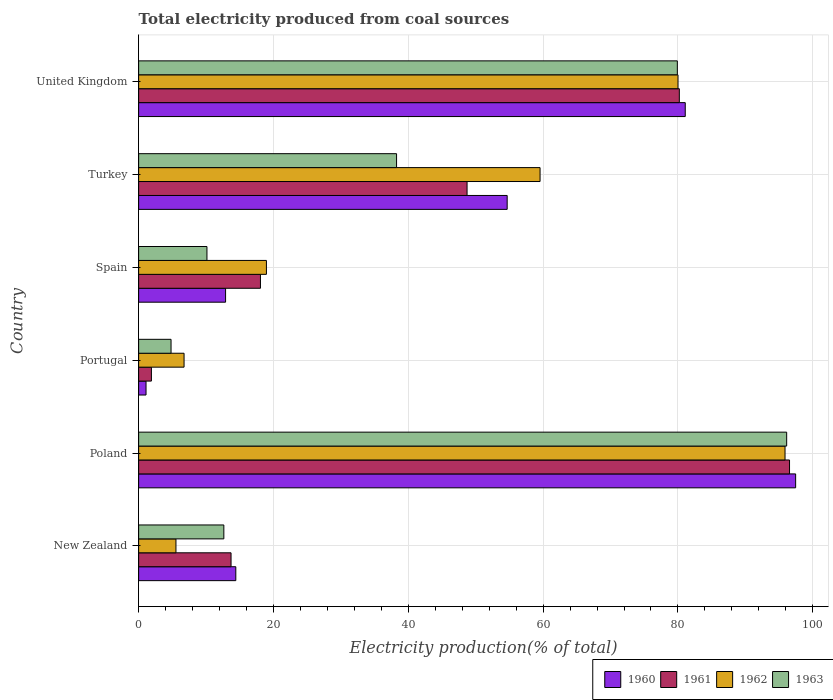How many different coloured bars are there?
Provide a short and direct response. 4. How many groups of bars are there?
Your response must be concise. 6. Are the number of bars on each tick of the Y-axis equal?
Provide a succinct answer. Yes. How many bars are there on the 6th tick from the top?
Ensure brevity in your answer.  4. How many bars are there on the 4th tick from the bottom?
Keep it short and to the point. 4. What is the label of the 6th group of bars from the top?
Provide a succinct answer. New Zealand. What is the total electricity produced in 1961 in Portugal?
Your answer should be compact. 1.89. Across all countries, what is the maximum total electricity produced in 1961?
Provide a short and direct response. 96.56. Across all countries, what is the minimum total electricity produced in 1962?
Provide a short and direct response. 5.54. In which country was the total electricity produced in 1963 maximum?
Keep it short and to the point. Poland. In which country was the total electricity produced in 1962 minimum?
Your answer should be very brief. New Zealand. What is the total total electricity produced in 1960 in the graph?
Your answer should be compact. 261.63. What is the difference between the total electricity produced in 1960 in Portugal and that in Spain?
Ensure brevity in your answer.  -11.8. What is the difference between the total electricity produced in 1963 in Poland and the total electricity produced in 1961 in Spain?
Offer a very short reply. 78.06. What is the average total electricity produced in 1960 per country?
Your answer should be compact. 43.61. What is the difference between the total electricity produced in 1962 and total electricity produced in 1960 in New Zealand?
Your answer should be compact. -8.88. What is the ratio of the total electricity produced in 1960 in Poland to that in United Kingdom?
Provide a succinct answer. 1.2. Is the difference between the total electricity produced in 1962 in Portugal and Turkey greater than the difference between the total electricity produced in 1960 in Portugal and Turkey?
Your answer should be very brief. Yes. What is the difference between the highest and the second highest total electricity produced in 1961?
Make the answer very short. 16.35. What is the difference between the highest and the lowest total electricity produced in 1960?
Your answer should be very brief. 96.36. In how many countries, is the total electricity produced in 1960 greater than the average total electricity produced in 1960 taken over all countries?
Provide a succinct answer. 3. What does the 4th bar from the top in Poland represents?
Offer a very short reply. 1960. What is the difference between two consecutive major ticks on the X-axis?
Offer a very short reply. 20. Are the values on the major ticks of X-axis written in scientific E-notation?
Provide a short and direct response. No. Does the graph contain grids?
Offer a terse response. Yes. Where does the legend appear in the graph?
Offer a terse response. Bottom right. How are the legend labels stacked?
Provide a succinct answer. Horizontal. What is the title of the graph?
Your answer should be compact. Total electricity produced from coal sources. Does "2012" appear as one of the legend labels in the graph?
Your response must be concise. No. What is the label or title of the Y-axis?
Make the answer very short. Country. What is the Electricity production(% of total) in 1960 in New Zealand?
Your answer should be very brief. 14.42. What is the Electricity production(% of total) of 1961 in New Zealand?
Offer a very short reply. 13.71. What is the Electricity production(% of total) of 1962 in New Zealand?
Offer a very short reply. 5.54. What is the Electricity production(% of total) in 1963 in New Zealand?
Make the answer very short. 12.64. What is the Electricity production(% of total) in 1960 in Poland?
Your response must be concise. 97.46. What is the Electricity production(% of total) of 1961 in Poland?
Your response must be concise. 96.56. What is the Electricity production(% of total) of 1962 in Poland?
Ensure brevity in your answer.  95.89. What is the Electricity production(% of total) of 1963 in Poland?
Make the answer very short. 96.13. What is the Electricity production(% of total) of 1960 in Portugal?
Ensure brevity in your answer.  1.1. What is the Electricity production(% of total) of 1961 in Portugal?
Provide a short and direct response. 1.89. What is the Electricity production(% of total) of 1962 in Portugal?
Keep it short and to the point. 6.74. What is the Electricity production(% of total) of 1963 in Portugal?
Your response must be concise. 4.81. What is the Electricity production(% of total) in 1960 in Spain?
Keep it short and to the point. 12.9. What is the Electricity production(% of total) of 1961 in Spain?
Your answer should be very brief. 18.07. What is the Electricity production(% of total) in 1962 in Spain?
Make the answer very short. 18.96. What is the Electricity production(% of total) in 1963 in Spain?
Your response must be concise. 10.14. What is the Electricity production(% of total) of 1960 in Turkey?
Your response must be concise. 54.67. What is the Electricity production(% of total) of 1961 in Turkey?
Provide a short and direct response. 48.72. What is the Electricity production(% of total) in 1962 in Turkey?
Ensure brevity in your answer.  59.55. What is the Electricity production(% of total) of 1963 in Turkey?
Offer a terse response. 38.26. What is the Electricity production(% of total) in 1960 in United Kingdom?
Give a very brief answer. 81.09. What is the Electricity production(% of total) in 1961 in United Kingdom?
Make the answer very short. 80.21. What is the Electricity production(% of total) of 1962 in United Kingdom?
Provide a short and direct response. 80.01. What is the Electricity production(% of total) in 1963 in United Kingdom?
Your response must be concise. 79.91. Across all countries, what is the maximum Electricity production(% of total) of 1960?
Offer a very short reply. 97.46. Across all countries, what is the maximum Electricity production(% of total) in 1961?
Your response must be concise. 96.56. Across all countries, what is the maximum Electricity production(% of total) in 1962?
Give a very brief answer. 95.89. Across all countries, what is the maximum Electricity production(% of total) in 1963?
Your answer should be very brief. 96.13. Across all countries, what is the minimum Electricity production(% of total) in 1960?
Your answer should be compact. 1.1. Across all countries, what is the minimum Electricity production(% of total) of 1961?
Make the answer very short. 1.89. Across all countries, what is the minimum Electricity production(% of total) of 1962?
Ensure brevity in your answer.  5.54. Across all countries, what is the minimum Electricity production(% of total) in 1963?
Your answer should be very brief. 4.81. What is the total Electricity production(% of total) of 1960 in the graph?
Your answer should be compact. 261.63. What is the total Electricity production(% of total) in 1961 in the graph?
Ensure brevity in your answer.  259.16. What is the total Electricity production(% of total) of 1962 in the graph?
Your answer should be compact. 266.69. What is the total Electricity production(% of total) of 1963 in the graph?
Your answer should be compact. 241.89. What is the difference between the Electricity production(% of total) of 1960 in New Zealand and that in Poland?
Make the answer very short. -83.05. What is the difference between the Electricity production(% of total) of 1961 in New Zealand and that in Poland?
Offer a very short reply. -82.85. What is the difference between the Electricity production(% of total) in 1962 in New Zealand and that in Poland?
Keep it short and to the point. -90.35. What is the difference between the Electricity production(% of total) in 1963 in New Zealand and that in Poland?
Provide a short and direct response. -83.49. What is the difference between the Electricity production(% of total) in 1960 in New Zealand and that in Portugal?
Ensure brevity in your answer.  13.32. What is the difference between the Electricity production(% of total) in 1961 in New Zealand and that in Portugal?
Provide a succinct answer. 11.81. What is the difference between the Electricity production(% of total) in 1962 in New Zealand and that in Portugal?
Provide a succinct answer. -1.2. What is the difference between the Electricity production(% of total) in 1963 in New Zealand and that in Portugal?
Offer a terse response. 7.83. What is the difference between the Electricity production(% of total) in 1960 in New Zealand and that in Spain?
Ensure brevity in your answer.  1.52. What is the difference between the Electricity production(% of total) of 1961 in New Zealand and that in Spain?
Your answer should be compact. -4.36. What is the difference between the Electricity production(% of total) in 1962 in New Zealand and that in Spain?
Give a very brief answer. -13.42. What is the difference between the Electricity production(% of total) in 1963 in New Zealand and that in Spain?
Give a very brief answer. 2.5. What is the difference between the Electricity production(% of total) of 1960 in New Zealand and that in Turkey?
Offer a very short reply. -40.25. What is the difference between the Electricity production(% of total) of 1961 in New Zealand and that in Turkey?
Ensure brevity in your answer.  -35.01. What is the difference between the Electricity production(% of total) in 1962 in New Zealand and that in Turkey?
Provide a succinct answer. -54.01. What is the difference between the Electricity production(% of total) of 1963 in New Zealand and that in Turkey?
Make the answer very short. -25.62. What is the difference between the Electricity production(% of total) of 1960 in New Zealand and that in United Kingdom?
Keep it short and to the point. -66.67. What is the difference between the Electricity production(% of total) in 1961 in New Zealand and that in United Kingdom?
Keep it short and to the point. -66.5. What is the difference between the Electricity production(% of total) in 1962 in New Zealand and that in United Kingdom?
Your answer should be compact. -74.48. What is the difference between the Electricity production(% of total) in 1963 in New Zealand and that in United Kingdom?
Ensure brevity in your answer.  -67.27. What is the difference between the Electricity production(% of total) of 1960 in Poland and that in Portugal?
Provide a succinct answer. 96.36. What is the difference between the Electricity production(% of total) in 1961 in Poland and that in Portugal?
Give a very brief answer. 94.66. What is the difference between the Electricity production(% of total) in 1962 in Poland and that in Portugal?
Offer a terse response. 89.15. What is the difference between the Electricity production(% of total) of 1963 in Poland and that in Portugal?
Your answer should be very brief. 91.32. What is the difference between the Electricity production(% of total) in 1960 in Poland and that in Spain?
Make the answer very short. 84.56. What is the difference between the Electricity production(% of total) in 1961 in Poland and that in Spain?
Give a very brief answer. 78.49. What is the difference between the Electricity production(% of total) in 1962 in Poland and that in Spain?
Your answer should be compact. 76.93. What is the difference between the Electricity production(% of total) in 1963 in Poland and that in Spain?
Your answer should be very brief. 86. What is the difference between the Electricity production(% of total) of 1960 in Poland and that in Turkey?
Your answer should be compact. 42.79. What is the difference between the Electricity production(% of total) in 1961 in Poland and that in Turkey?
Make the answer very short. 47.84. What is the difference between the Electricity production(% of total) in 1962 in Poland and that in Turkey?
Your answer should be compact. 36.34. What is the difference between the Electricity production(% of total) in 1963 in Poland and that in Turkey?
Provide a short and direct response. 57.87. What is the difference between the Electricity production(% of total) of 1960 in Poland and that in United Kingdom?
Your response must be concise. 16.38. What is the difference between the Electricity production(% of total) of 1961 in Poland and that in United Kingdom?
Offer a terse response. 16.35. What is the difference between the Electricity production(% of total) in 1962 in Poland and that in United Kingdom?
Offer a terse response. 15.87. What is the difference between the Electricity production(% of total) of 1963 in Poland and that in United Kingdom?
Ensure brevity in your answer.  16.22. What is the difference between the Electricity production(% of total) of 1960 in Portugal and that in Spain?
Provide a succinct answer. -11.8. What is the difference between the Electricity production(% of total) in 1961 in Portugal and that in Spain?
Ensure brevity in your answer.  -16.18. What is the difference between the Electricity production(% of total) in 1962 in Portugal and that in Spain?
Make the answer very short. -12.22. What is the difference between the Electricity production(% of total) in 1963 in Portugal and that in Spain?
Your answer should be compact. -5.33. What is the difference between the Electricity production(% of total) in 1960 in Portugal and that in Turkey?
Your answer should be very brief. -53.57. What is the difference between the Electricity production(% of total) in 1961 in Portugal and that in Turkey?
Provide a succinct answer. -46.83. What is the difference between the Electricity production(% of total) in 1962 in Portugal and that in Turkey?
Offer a very short reply. -52.81. What is the difference between the Electricity production(% of total) of 1963 in Portugal and that in Turkey?
Offer a terse response. -33.45. What is the difference between the Electricity production(% of total) of 1960 in Portugal and that in United Kingdom?
Your answer should be compact. -79.99. What is the difference between the Electricity production(% of total) of 1961 in Portugal and that in United Kingdom?
Provide a short and direct response. -78.31. What is the difference between the Electricity production(% of total) of 1962 in Portugal and that in United Kingdom?
Your response must be concise. -73.27. What is the difference between the Electricity production(% of total) of 1963 in Portugal and that in United Kingdom?
Give a very brief answer. -75.1. What is the difference between the Electricity production(% of total) in 1960 in Spain and that in Turkey?
Give a very brief answer. -41.77. What is the difference between the Electricity production(% of total) in 1961 in Spain and that in Turkey?
Your answer should be very brief. -30.65. What is the difference between the Electricity production(% of total) in 1962 in Spain and that in Turkey?
Give a very brief answer. -40.59. What is the difference between the Electricity production(% of total) of 1963 in Spain and that in Turkey?
Keep it short and to the point. -28.13. What is the difference between the Electricity production(% of total) of 1960 in Spain and that in United Kingdom?
Your answer should be compact. -68.19. What is the difference between the Electricity production(% of total) of 1961 in Spain and that in United Kingdom?
Provide a short and direct response. -62.14. What is the difference between the Electricity production(% of total) of 1962 in Spain and that in United Kingdom?
Offer a very short reply. -61.06. What is the difference between the Electricity production(% of total) of 1963 in Spain and that in United Kingdom?
Your answer should be compact. -69.78. What is the difference between the Electricity production(% of total) in 1960 in Turkey and that in United Kingdom?
Your answer should be compact. -26.41. What is the difference between the Electricity production(% of total) in 1961 in Turkey and that in United Kingdom?
Provide a succinct answer. -31.49. What is the difference between the Electricity production(% of total) of 1962 in Turkey and that in United Kingdom?
Provide a short and direct response. -20.46. What is the difference between the Electricity production(% of total) in 1963 in Turkey and that in United Kingdom?
Ensure brevity in your answer.  -41.65. What is the difference between the Electricity production(% of total) of 1960 in New Zealand and the Electricity production(% of total) of 1961 in Poland?
Offer a very short reply. -82.14. What is the difference between the Electricity production(% of total) of 1960 in New Zealand and the Electricity production(% of total) of 1962 in Poland?
Your answer should be compact. -81.47. What is the difference between the Electricity production(% of total) of 1960 in New Zealand and the Electricity production(% of total) of 1963 in Poland?
Provide a succinct answer. -81.71. What is the difference between the Electricity production(% of total) in 1961 in New Zealand and the Electricity production(% of total) in 1962 in Poland?
Give a very brief answer. -82.18. What is the difference between the Electricity production(% of total) of 1961 in New Zealand and the Electricity production(% of total) of 1963 in Poland?
Give a very brief answer. -82.42. What is the difference between the Electricity production(% of total) in 1962 in New Zealand and the Electricity production(% of total) in 1963 in Poland?
Offer a terse response. -90.6. What is the difference between the Electricity production(% of total) of 1960 in New Zealand and the Electricity production(% of total) of 1961 in Portugal?
Offer a very short reply. 12.52. What is the difference between the Electricity production(% of total) in 1960 in New Zealand and the Electricity production(% of total) in 1962 in Portugal?
Give a very brief answer. 7.68. What is the difference between the Electricity production(% of total) in 1960 in New Zealand and the Electricity production(% of total) in 1963 in Portugal?
Offer a terse response. 9.61. What is the difference between the Electricity production(% of total) of 1961 in New Zealand and the Electricity production(% of total) of 1962 in Portugal?
Offer a terse response. 6.97. What is the difference between the Electricity production(% of total) of 1961 in New Zealand and the Electricity production(% of total) of 1963 in Portugal?
Keep it short and to the point. 8.9. What is the difference between the Electricity production(% of total) in 1962 in New Zealand and the Electricity production(% of total) in 1963 in Portugal?
Make the answer very short. 0.73. What is the difference between the Electricity production(% of total) of 1960 in New Zealand and the Electricity production(% of total) of 1961 in Spain?
Ensure brevity in your answer.  -3.65. What is the difference between the Electricity production(% of total) in 1960 in New Zealand and the Electricity production(% of total) in 1962 in Spain?
Offer a terse response. -4.54. What is the difference between the Electricity production(% of total) of 1960 in New Zealand and the Electricity production(% of total) of 1963 in Spain?
Your response must be concise. 4.28. What is the difference between the Electricity production(% of total) of 1961 in New Zealand and the Electricity production(% of total) of 1962 in Spain?
Provide a short and direct response. -5.25. What is the difference between the Electricity production(% of total) of 1961 in New Zealand and the Electricity production(% of total) of 1963 in Spain?
Keep it short and to the point. 3.57. What is the difference between the Electricity production(% of total) in 1962 in New Zealand and the Electricity production(% of total) in 1963 in Spain?
Give a very brief answer. -4.6. What is the difference between the Electricity production(% of total) of 1960 in New Zealand and the Electricity production(% of total) of 1961 in Turkey?
Make the answer very short. -34.3. What is the difference between the Electricity production(% of total) of 1960 in New Zealand and the Electricity production(% of total) of 1962 in Turkey?
Offer a terse response. -45.13. What is the difference between the Electricity production(% of total) of 1960 in New Zealand and the Electricity production(% of total) of 1963 in Turkey?
Provide a short and direct response. -23.85. What is the difference between the Electricity production(% of total) in 1961 in New Zealand and the Electricity production(% of total) in 1962 in Turkey?
Provide a succinct answer. -45.84. What is the difference between the Electricity production(% of total) of 1961 in New Zealand and the Electricity production(% of total) of 1963 in Turkey?
Your answer should be compact. -24.55. What is the difference between the Electricity production(% of total) in 1962 in New Zealand and the Electricity production(% of total) in 1963 in Turkey?
Ensure brevity in your answer.  -32.73. What is the difference between the Electricity production(% of total) of 1960 in New Zealand and the Electricity production(% of total) of 1961 in United Kingdom?
Ensure brevity in your answer.  -65.79. What is the difference between the Electricity production(% of total) in 1960 in New Zealand and the Electricity production(% of total) in 1962 in United Kingdom?
Offer a terse response. -65.6. What is the difference between the Electricity production(% of total) of 1960 in New Zealand and the Electricity production(% of total) of 1963 in United Kingdom?
Your response must be concise. -65.5. What is the difference between the Electricity production(% of total) of 1961 in New Zealand and the Electricity production(% of total) of 1962 in United Kingdom?
Offer a very short reply. -66.31. What is the difference between the Electricity production(% of total) of 1961 in New Zealand and the Electricity production(% of total) of 1963 in United Kingdom?
Keep it short and to the point. -66.21. What is the difference between the Electricity production(% of total) in 1962 in New Zealand and the Electricity production(% of total) in 1963 in United Kingdom?
Offer a very short reply. -74.38. What is the difference between the Electricity production(% of total) in 1960 in Poland and the Electricity production(% of total) in 1961 in Portugal?
Provide a succinct answer. 95.57. What is the difference between the Electricity production(% of total) in 1960 in Poland and the Electricity production(% of total) in 1962 in Portugal?
Provide a succinct answer. 90.72. What is the difference between the Electricity production(% of total) in 1960 in Poland and the Electricity production(% of total) in 1963 in Portugal?
Provide a succinct answer. 92.65. What is the difference between the Electricity production(% of total) in 1961 in Poland and the Electricity production(% of total) in 1962 in Portugal?
Offer a very short reply. 89.82. What is the difference between the Electricity production(% of total) in 1961 in Poland and the Electricity production(% of total) in 1963 in Portugal?
Offer a terse response. 91.75. What is the difference between the Electricity production(% of total) in 1962 in Poland and the Electricity production(% of total) in 1963 in Portugal?
Make the answer very short. 91.08. What is the difference between the Electricity production(% of total) in 1960 in Poland and the Electricity production(% of total) in 1961 in Spain?
Make the answer very short. 79.39. What is the difference between the Electricity production(% of total) of 1960 in Poland and the Electricity production(% of total) of 1962 in Spain?
Ensure brevity in your answer.  78.51. What is the difference between the Electricity production(% of total) in 1960 in Poland and the Electricity production(% of total) in 1963 in Spain?
Ensure brevity in your answer.  87.33. What is the difference between the Electricity production(% of total) in 1961 in Poland and the Electricity production(% of total) in 1962 in Spain?
Your response must be concise. 77.6. What is the difference between the Electricity production(% of total) in 1961 in Poland and the Electricity production(% of total) in 1963 in Spain?
Your response must be concise. 86.42. What is the difference between the Electricity production(% of total) in 1962 in Poland and the Electricity production(% of total) in 1963 in Spain?
Provide a short and direct response. 85.75. What is the difference between the Electricity production(% of total) of 1960 in Poland and the Electricity production(% of total) of 1961 in Turkey?
Provide a succinct answer. 48.74. What is the difference between the Electricity production(% of total) in 1960 in Poland and the Electricity production(% of total) in 1962 in Turkey?
Keep it short and to the point. 37.91. What is the difference between the Electricity production(% of total) of 1960 in Poland and the Electricity production(% of total) of 1963 in Turkey?
Provide a succinct answer. 59.2. What is the difference between the Electricity production(% of total) of 1961 in Poland and the Electricity production(% of total) of 1962 in Turkey?
Provide a short and direct response. 37.01. What is the difference between the Electricity production(% of total) in 1961 in Poland and the Electricity production(% of total) in 1963 in Turkey?
Provide a succinct answer. 58.29. What is the difference between the Electricity production(% of total) of 1962 in Poland and the Electricity production(% of total) of 1963 in Turkey?
Provide a succinct answer. 57.63. What is the difference between the Electricity production(% of total) of 1960 in Poland and the Electricity production(% of total) of 1961 in United Kingdom?
Offer a terse response. 17.26. What is the difference between the Electricity production(% of total) of 1960 in Poland and the Electricity production(% of total) of 1962 in United Kingdom?
Your answer should be very brief. 17.45. What is the difference between the Electricity production(% of total) in 1960 in Poland and the Electricity production(% of total) in 1963 in United Kingdom?
Your answer should be compact. 17.55. What is the difference between the Electricity production(% of total) in 1961 in Poland and the Electricity production(% of total) in 1962 in United Kingdom?
Provide a short and direct response. 16.54. What is the difference between the Electricity production(% of total) in 1961 in Poland and the Electricity production(% of total) in 1963 in United Kingdom?
Provide a short and direct response. 16.64. What is the difference between the Electricity production(% of total) in 1962 in Poland and the Electricity production(% of total) in 1963 in United Kingdom?
Keep it short and to the point. 15.97. What is the difference between the Electricity production(% of total) of 1960 in Portugal and the Electricity production(% of total) of 1961 in Spain?
Provide a short and direct response. -16.97. What is the difference between the Electricity production(% of total) in 1960 in Portugal and the Electricity production(% of total) in 1962 in Spain?
Ensure brevity in your answer.  -17.86. What is the difference between the Electricity production(% of total) in 1960 in Portugal and the Electricity production(% of total) in 1963 in Spain?
Offer a very short reply. -9.04. What is the difference between the Electricity production(% of total) of 1961 in Portugal and the Electricity production(% of total) of 1962 in Spain?
Your answer should be compact. -17.06. What is the difference between the Electricity production(% of total) in 1961 in Portugal and the Electricity production(% of total) in 1963 in Spain?
Provide a short and direct response. -8.24. What is the difference between the Electricity production(% of total) in 1962 in Portugal and the Electricity production(% of total) in 1963 in Spain?
Your answer should be compact. -3.4. What is the difference between the Electricity production(% of total) in 1960 in Portugal and the Electricity production(% of total) in 1961 in Turkey?
Keep it short and to the point. -47.62. What is the difference between the Electricity production(% of total) in 1960 in Portugal and the Electricity production(% of total) in 1962 in Turkey?
Your answer should be very brief. -58.45. What is the difference between the Electricity production(% of total) of 1960 in Portugal and the Electricity production(% of total) of 1963 in Turkey?
Offer a very short reply. -37.16. What is the difference between the Electricity production(% of total) of 1961 in Portugal and the Electricity production(% of total) of 1962 in Turkey?
Your answer should be compact. -57.66. What is the difference between the Electricity production(% of total) of 1961 in Portugal and the Electricity production(% of total) of 1963 in Turkey?
Give a very brief answer. -36.37. What is the difference between the Electricity production(% of total) in 1962 in Portugal and the Electricity production(% of total) in 1963 in Turkey?
Keep it short and to the point. -31.52. What is the difference between the Electricity production(% of total) of 1960 in Portugal and the Electricity production(% of total) of 1961 in United Kingdom?
Offer a terse response. -79.11. What is the difference between the Electricity production(% of total) of 1960 in Portugal and the Electricity production(% of total) of 1962 in United Kingdom?
Provide a succinct answer. -78.92. What is the difference between the Electricity production(% of total) in 1960 in Portugal and the Electricity production(% of total) in 1963 in United Kingdom?
Your answer should be compact. -78.82. What is the difference between the Electricity production(% of total) in 1961 in Portugal and the Electricity production(% of total) in 1962 in United Kingdom?
Give a very brief answer. -78.12. What is the difference between the Electricity production(% of total) in 1961 in Portugal and the Electricity production(% of total) in 1963 in United Kingdom?
Give a very brief answer. -78.02. What is the difference between the Electricity production(% of total) of 1962 in Portugal and the Electricity production(% of total) of 1963 in United Kingdom?
Your response must be concise. -73.17. What is the difference between the Electricity production(% of total) in 1960 in Spain and the Electricity production(% of total) in 1961 in Turkey?
Your answer should be very brief. -35.82. What is the difference between the Electricity production(% of total) in 1960 in Spain and the Electricity production(% of total) in 1962 in Turkey?
Ensure brevity in your answer.  -46.65. What is the difference between the Electricity production(% of total) in 1960 in Spain and the Electricity production(% of total) in 1963 in Turkey?
Your answer should be very brief. -25.36. What is the difference between the Electricity production(% of total) in 1961 in Spain and the Electricity production(% of total) in 1962 in Turkey?
Make the answer very short. -41.48. What is the difference between the Electricity production(% of total) of 1961 in Spain and the Electricity production(% of total) of 1963 in Turkey?
Your answer should be compact. -20.19. What is the difference between the Electricity production(% of total) of 1962 in Spain and the Electricity production(% of total) of 1963 in Turkey?
Your response must be concise. -19.31. What is the difference between the Electricity production(% of total) in 1960 in Spain and the Electricity production(% of total) in 1961 in United Kingdom?
Give a very brief answer. -67.31. What is the difference between the Electricity production(% of total) in 1960 in Spain and the Electricity production(% of total) in 1962 in United Kingdom?
Your answer should be very brief. -67.12. What is the difference between the Electricity production(% of total) in 1960 in Spain and the Electricity production(% of total) in 1963 in United Kingdom?
Your response must be concise. -67.02. What is the difference between the Electricity production(% of total) of 1961 in Spain and the Electricity production(% of total) of 1962 in United Kingdom?
Provide a short and direct response. -61.94. What is the difference between the Electricity production(% of total) of 1961 in Spain and the Electricity production(% of total) of 1963 in United Kingdom?
Make the answer very short. -61.84. What is the difference between the Electricity production(% of total) in 1962 in Spain and the Electricity production(% of total) in 1963 in United Kingdom?
Offer a terse response. -60.96. What is the difference between the Electricity production(% of total) of 1960 in Turkey and the Electricity production(% of total) of 1961 in United Kingdom?
Make the answer very short. -25.54. What is the difference between the Electricity production(% of total) of 1960 in Turkey and the Electricity production(% of total) of 1962 in United Kingdom?
Your answer should be very brief. -25.34. What is the difference between the Electricity production(% of total) in 1960 in Turkey and the Electricity production(% of total) in 1963 in United Kingdom?
Offer a terse response. -25.24. What is the difference between the Electricity production(% of total) of 1961 in Turkey and the Electricity production(% of total) of 1962 in United Kingdom?
Your answer should be compact. -31.29. What is the difference between the Electricity production(% of total) in 1961 in Turkey and the Electricity production(% of total) in 1963 in United Kingdom?
Provide a short and direct response. -31.19. What is the difference between the Electricity production(% of total) in 1962 in Turkey and the Electricity production(% of total) in 1963 in United Kingdom?
Give a very brief answer. -20.36. What is the average Electricity production(% of total) of 1960 per country?
Your answer should be very brief. 43.61. What is the average Electricity production(% of total) of 1961 per country?
Your answer should be compact. 43.19. What is the average Electricity production(% of total) in 1962 per country?
Provide a short and direct response. 44.45. What is the average Electricity production(% of total) of 1963 per country?
Your answer should be very brief. 40.32. What is the difference between the Electricity production(% of total) in 1960 and Electricity production(% of total) in 1961 in New Zealand?
Provide a succinct answer. 0.71. What is the difference between the Electricity production(% of total) of 1960 and Electricity production(% of total) of 1962 in New Zealand?
Offer a very short reply. 8.88. What is the difference between the Electricity production(% of total) in 1960 and Electricity production(% of total) in 1963 in New Zealand?
Ensure brevity in your answer.  1.78. What is the difference between the Electricity production(% of total) of 1961 and Electricity production(% of total) of 1962 in New Zealand?
Make the answer very short. 8.17. What is the difference between the Electricity production(% of total) of 1961 and Electricity production(% of total) of 1963 in New Zealand?
Your response must be concise. 1.07. What is the difference between the Electricity production(% of total) of 1962 and Electricity production(% of total) of 1963 in New Zealand?
Provide a succinct answer. -7.1. What is the difference between the Electricity production(% of total) in 1960 and Electricity production(% of total) in 1961 in Poland?
Offer a terse response. 0.91. What is the difference between the Electricity production(% of total) in 1960 and Electricity production(% of total) in 1962 in Poland?
Offer a very short reply. 1.57. What is the difference between the Electricity production(% of total) in 1960 and Electricity production(% of total) in 1963 in Poland?
Ensure brevity in your answer.  1.33. What is the difference between the Electricity production(% of total) in 1961 and Electricity production(% of total) in 1962 in Poland?
Provide a succinct answer. 0.67. What is the difference between the Electricity production(% of total) of 1961 and Electricity production(% of total) of 1963 in Poland?
Keep it short and to the point. 0.43. What is the difference between the Electricity production(% of total) in 1962 and Electricity production(% of total) in 1963 in Poland?
Keep it short and to the point. -0.24. What is the difference between the Electricity production(% of total) of 1960 and Electricity production(% of total) of 1961 in Portugal?
Provide a short and direct response. -0.8. What is the difference between the Electricity production(% of total) in 1960 and Electricity production(% of total) in 1962 in Portugal?
Provide a short and direct response. -5.64. What is the difference between the Electricity production(% of total) in 1960 and Electricity production(% of total) in 1963 in Portugal?
Offer a very short reply. -3.71. What is the difference between the Electricity production(% of total) in 1961 and Electricity production(% of total) in 1962 in Portugal?
Make the answer very short. -4.85. What is the difference between the Electricity production(% of total) in 1961 and Electricity production(% of total) in 1963 in Portugal?
Make the answer very short. -2.91. What is the difference between the Electricity production(% of total) of 1962 and Electricity production(% of total) of 1963 in Portugal?
Your answer should be compact. 1.93. What is the difference between the Electricity production(% of total) of 1960 and Electricity production(% of total) of 1961 in Spain?
Ensure brevity in your answer.  -5.17. What is the difference between the Electricity production(% of total) in 1960 and Electricity production(% of total) in 1962 in Spain?
Your answer should be very brief. -6.06. What is the difference between the Electricity production(% of total) in 1960 and Electricity production(% of total) in 1963 in Spain?
Give a very brief answer. 2.76. What is the difference between the Electricity production(% of total) of 1961 and Electricity production(% of total) of 1962 in Spain?
Make the answer very short. -0.88. What is the difference between the Electricity production(% of total) of 1961 and Electricity production(% of total) of 1963 in Spain?
Offer a terse response. 7.94. What is the difference between the Electricity production(% of total) in 1962 and Electricity production(% of total) in 1963 in Spain?
Make the answer very short. 8.82. What is the difference between the Electricity production(% of total) of 1960 and Electricity production(% of total) of 1961 in Turkey?
Provide a short and direct response. 5.95. What is the difference between the Electricity production(% of total) of 1960 and Electricity production(% of total) of 1962 in Turkey?
Your answer should be compact. -4.88. What is the difference between the Electricity production(% of total) in 1960 and Electricity production(% of total) in 1963 in Turkey?
Your answer should be very brief. 16.41. What is the difference between the Electricity production(% of total) in 1961 and Electricity production(% of total) in 1962 in Turkey?
Your response must be concise. -10.83. What is the difference between the Electricity production(% of total) of 1961 and Electricity production(% of total) of 1963 in Turkey?
Provide a short and direct response. 10.46. What is the difference between the Electricity production(% of total) of 1962 and Electricity production(% of total) of 1963 in Turkey?
Make the answer very short. 21.29. What is the difference between the Electricity production(% of total) of 1960 and Electricity production(% of total) of 1961 in United Kingdom?
Give a very brief answer. 0.88. What is the difference between the Electricity production(% of total) in 1960 and Electricity production(% of total) in 1962 in United Kingdom?
Your answer should be very brief. 1.07. What is the difference between the Electricity production(% of total) in 1960 and Electricity production(% of total) in 1963 in United Kingdom?
Your answer should be very brief. 1.17. What is the difference between the Electricity production(% of total) of 1961 and Electricity production(% of total) of 1962 in United Kingdom?
Give a very brief answer. 0.19. What is the difference between the Electricity production(% of total) of 1961 and Electricity production(% of total) of 1963 in United Kingdom?
Keep it short and to the point. 0.29. What is the difference between the Electricity production(% of total) of 1962 and Electricity production(% of total) of 1963 in United Kingdom?
Offer a very short reply. 0.1. What is the ratio of the Electricity production(% of total) of 1960 in New Zealand to that in Poland?
Your answer should be very brief. 0.15. What is the ratio of the Electricity production(% of total) of 1961 in New Zealand to that in Poland?
Offer a very short reply. 0.14. What is the ratio of the Electricity production(% of total) in 1962 in New Zealand to that in Poland?
Your answer should be compact. 0.06. What is the ratio of the Electricity production(% of total) in 1963 in New Zealand to that in Poland?
Your answer should be very brief. 0.13. What is the ratio of the Electricity production(% of total) in 1960 in New Zealand to that in Portugal?
Offer a terse response. 13.13. What is the ratio of the Electricity production(% of total) of 1961 in New Zealand to that in Portugal?
Make the answer very short. 7.24. What is the ratio of the Electricity production(% of total) in 1962 in New Zealand to that in Portugal?
Your response must be concise. 0.82. What is the ratio of the Electricity production(% of total) in 1963 in New Zealand to that in Portugal?
Offer a very short reply. 2.63. What is the ratio of the Electricity production(% of total) of 1960 in New Zealand to that in Spain?
Your response must be concise. 1.12. What is the ratio of the Electricity production(% of total) of 1961 in New Zealand to that in Spain?
Provide a short and direct response. 0.76. What is the ratio of the Electricity production(% of total) in 1962 in New Zealand to that in Spain?
Give a very brief answer. 0.29. What is the ratio of the Electricity production(% of total) in 1963 in New Zealand to that in Spain?
Your answer should be very brief. 1.25. What is the ratio of the Electricity production(% of total) in 1960 in New Zealand to that in Turkey?
Offer a terse response. 0.26. What is the ratio of the Electricity production(% of total) of 1961 in New Zealand to that in Turkey?
Your answer should be very brief. 0.28. What is the ratio of the Electricity production(% of total) of 1962 in New Zealand to that in Turkey?
Provide a succinct answer. 0.09. What is the ratio of the Electricity production(% of total) of 1963 in New Zealand to that in Turkey?
Offer a very short reply. 0.33. What is the ratio of the Electricity production(% of total) in 1960 in New Zealand to that in United Kingdom?
Provide a short and direct response. 0.18. What is the ratio of the Electricity production(% of total) of 1961 in New Zealand to that in United Kingdom?
Keep it short and to the point. 0.17. What is the ratio of the Electricity production(% of total) in 1962 in New Zealand to that in United Kingdom?
Make the answer very short. 0.07. What is the ratio of the Electricity production(% of total) in 1963 in New Zealand to that in United Kingdom?
Your response must be concise. 0.16. What is the ratio of the Electricity production(% of total) in 1960 in Poland to that in Portugal?
Your answer should be compact. 88.77. What is the ratio of the Electricity production(% of total) in 1961 in Poland to that in Portugal?
Provide a succinct answer. 50.97. What is the ratio of the Electricity production(% of total) of 1962 in Poland to that in Portugal?
Your answer should be very brief. 14.23. What is the ratio of the Electricity production(% of total) of 1963 in Poland to that in Portugal?
Keep it short and to the point. 19.99. What is the ratio of the Electricity production(% of total) of 1960 in Poland to that in Spain?
Offer a terse response. 7.56. What is the ratio of the Electricity production(% of total) of 1961 in Poland to that in Spain?
Your response must be concise. 5.34. What is the ratio of the Electricity production(% of total) of 1962 in Poland to that in Spain?
Make the answer very short. 5.06. What is the ratio of the Electricity production(% of total) in 1963 in Poland to that in Spain?
Give a very brief answer. 9.48. What is the ratio of the Electricity production(% of total) in 1960 in Poland to that in Turkey?
Offer a very short reply. 1.78. What is the ratio of the Electricity production(% of total) in 1961 in Poland to that in Turkey?
Your answer should be compact. 1.98. What is the ratio of the Electricity production(% of total) in 1962 in Poland to that in Turkey?
Provide a succinct answer. 1.61. What is the ratio of the Electricity production(% of total) in 1963 in Poland to that in Turkey?
Give a very brief answer. 2.51. What is the ratio of the Electricity production(% of total) of 1960 in Poland to that in United Kingdom?
Keep it short and to the point. 1.2. What is the ratio of the Electricity production(% of total) of 1961 in Poland to that in United Kingdom?
Your answer should be very brief. 1.2. What is the ratio of the Electricity production(% of total) of 1962 in Poland to that in United Kingdom?
Offer a terse response. 1.2. What is the ratio of the Electricity production(% of total) of 1963 in Poland to that in United Kingdom?
Your answer should be compact. 1.2. What is the ratio of the Electricity production(% of total) in 1960 in Portugal to that in Spain?
Provide a succinct answer. 0.09. What is the ratio of the Electricity production(% of total) of 1961 in Portugal to that in Spain?
Keep it short and to the point. 0.1. What is the ratio of the Electricity production(% of total) in 1962 in Portugal to that in Spain?
Provide a short and direct response. 0.36. What is the ratio of the Electricity production(% of total) of 1963 in Portugal to that in Spain?
Your answer should be very brief. 0.47. What is the ratio of the Electricity production(% of total) in 1960 in Portugal to that in Turkey?
Offer a very short reply. 0.02. What is the ratio of the Electricity production(% of total) in 1961 in Portugal to that in Turkey?
Your answer should be compact. 0.04. What is the ratio of the Electricity production(% of total) in 1962 in Portugal to that in Turkey?
Keep it short and to the point. 0.11. What is the ratio of the Electricity production(% of total) of 1963 in Portugal to that in Turkey?
Your answer should be compact. 0.13. What is the ratio of the Electricity production(% of total) in 1960 in Portugal to that in United Kingdom?
Provide a short and direct response. 0.01. What is the ratio of the Electricity production(% of total) in 1961 in Portugal to that in United Kingdom?
Offer a very short reply. 0.02. What is the ratio of the Electricity production(% of total) of 1962 in Portugal to that in United Kingdom?
Provide a succinct answer. 0.08. What is the ratio of the Electricity production(% of total) of 1963 in Portugal to that in United Kingdom?
Make the answer very short. 0.06. What is the ratio of the Electricity production(% of total) of 1960 in Spain to that in Turkey?
Give a very brief answer. 0.24. What is the ratio of the Electricity production(% of total) of 1961 in Spain to that in Turkey?
Give a very brief answer. 0.37. What is the ratio of the Electricity production(% of total) of 1962 in Spain to that in Turkey?
Your answer should be compact. 0.32. What is the ratio of the Electricity production(% of total) of 1963 in Spain to that in Turkey?
Provide a short and direct response. 0.26. What is the ratio of the Electricity production(% of total) of 1960 in Spain to that in United Kingdom?
Make the answer very short. 0.16. What is the ratio of the Electricity production(% of total) of 1961 in Spain to that in United Kingdom?
Ensure brevity in your answer.  0.23. What is the ratio of the Electricity production(% of total) in 1962 in Spain to that in United Kingdom?
Offer a terse response. 0.24. What is the ratio of the Electricity production(% of total) of 1963 in Spain to that in United Kingdom?
Your response must be concise. 0.13. What is the ratio of the Electricity production(% of total) of 1960 in Turkey to that in United Kingdom?
Your answer should be very brief. 0.67. What is the ratio of the Electricity production(% of total) in 1961 in Turkey to that in United Kingdom?
Offer a very short reply. 0.61. What is the ratio of the Electricity production(% of total) in 1962 in Turkey to that in United Kingdom?
Ensure brevity in your answer.  0.74. What is the ratio of the Electricity production(% of total) of 1963 in Turkey to that in United Kingdom?
Your answer should be compact. 0.48. What is the difference between the highest and the second highest Electricity production(% of total) of 1960?
Your answer should be compact. 16.38. What is the difference between the highest and the second highest Electricity production(% of total) of 1961?
Provide a succinct answer. 16.35. What is the difference between the highest and the second highest Electricity production(% of total) of 1962?
Provide a succinct answer. 15.87. What is the difference between the highest and the second highest Electricity production(% of total) in 1963?
Provide a succinct answer. 16.22. What is the difference between the highest and the lowest Electricity production(% of total) in 1960?
Keep it short and to the point. 96.36. What is the difference between the highest and the lowest Electricity production(% of total) in 1961?
Provide a short and direct response. 94.66. What is the difference between the highest and the lowest Electricity production(% of total) in 1962?
Your answer should be very brief. 90.35. What is the difference between the highest and the lowest Electricity production(% of total) in 1963?
Offer a very short reply. 91.32. 